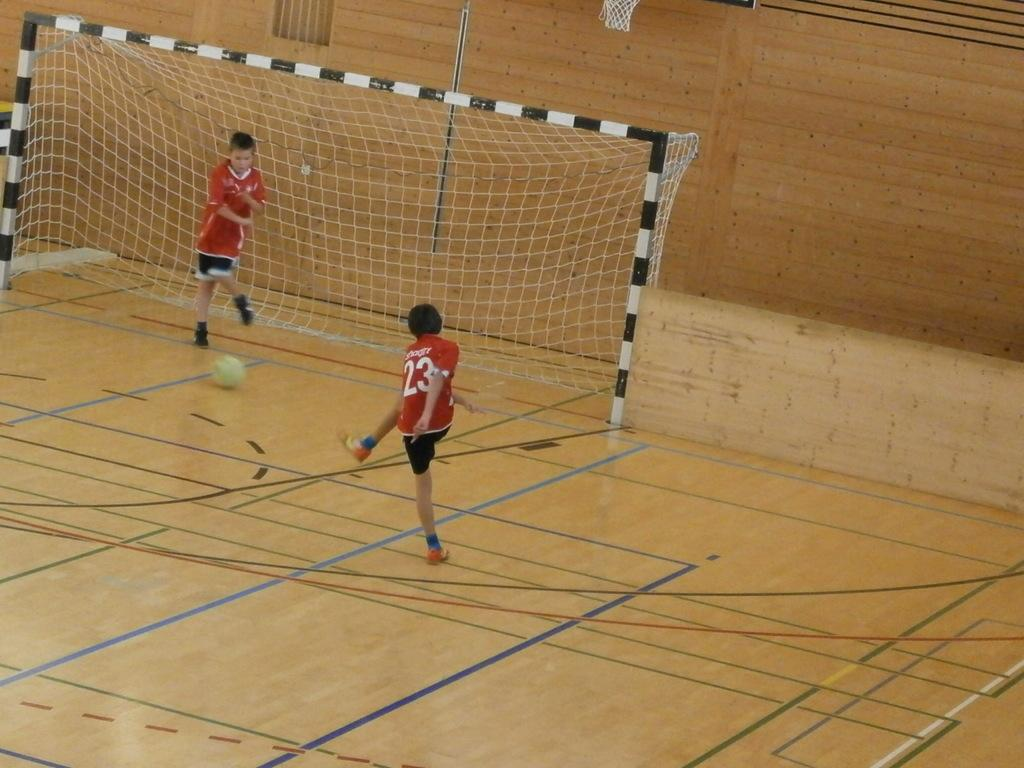<image>
Relay a brief, clear account of the picture shown. Player number 23 shoots the soccer ball at the goal. 